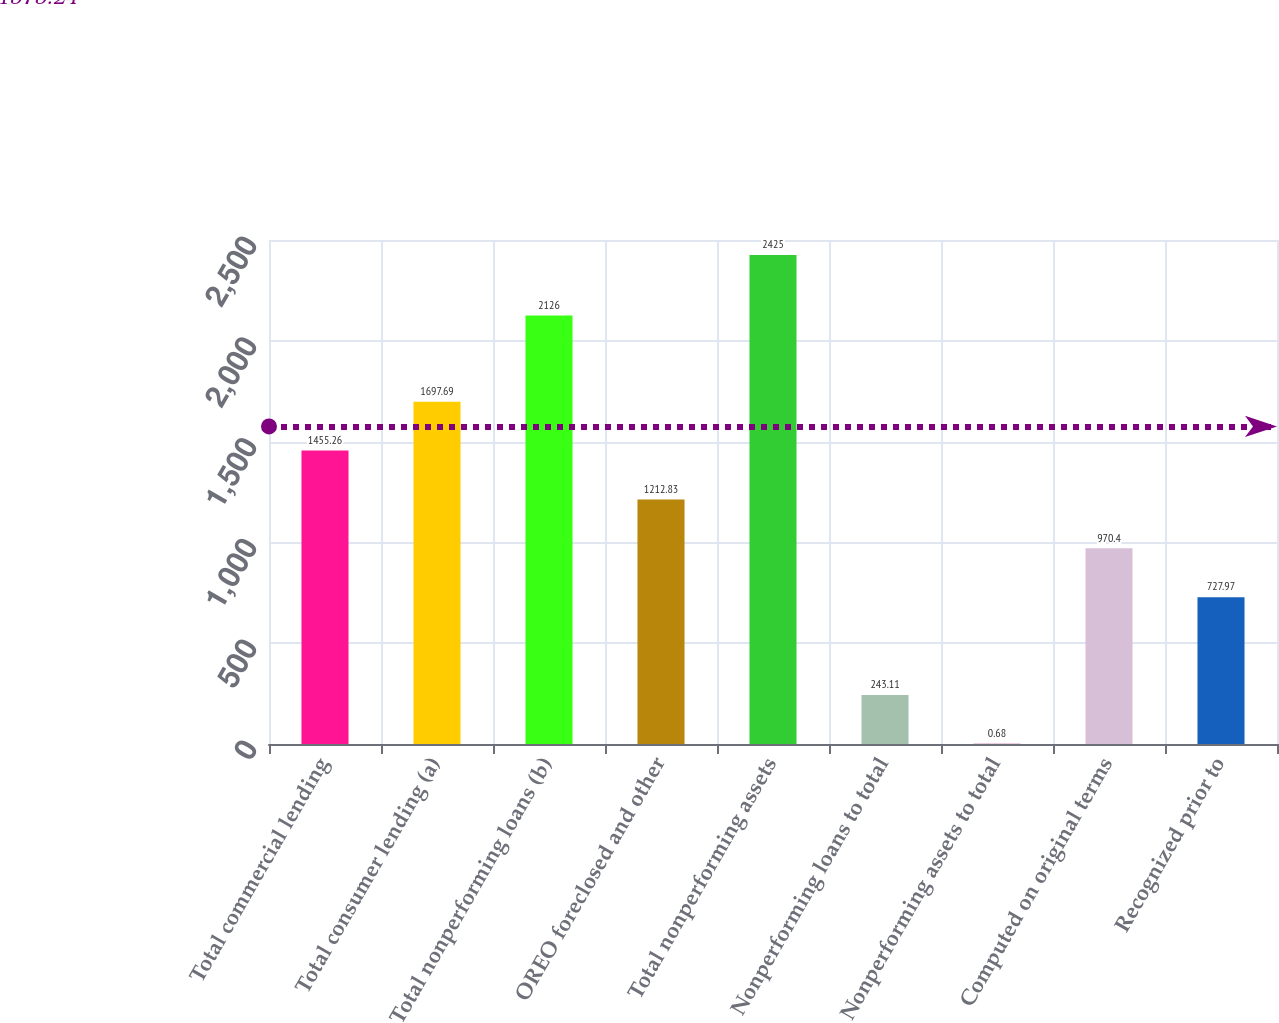<chart> <loc_0><loc_0><loc_500><loc_500><bar_chart><fcel>Total commercial lending<fcel>Total consumer lending (a)<fcel>Total nonperforming loans (b)<fcel>OREO foreclosed and other<fcel>Total nonperforming assets<fcel>Nonperforming loans to total<fcel>Nonperforming assets to total<fcel>Computed on original terms<fcel>Recognized prior to<nl><fcel>1455.26<fcel>1697.69<fcel>2126<fcel>1212.83<fcel>2425<fcel>243.11<fcel>0.68<fcel>970.4<fcel>727.97<nl></chart> 